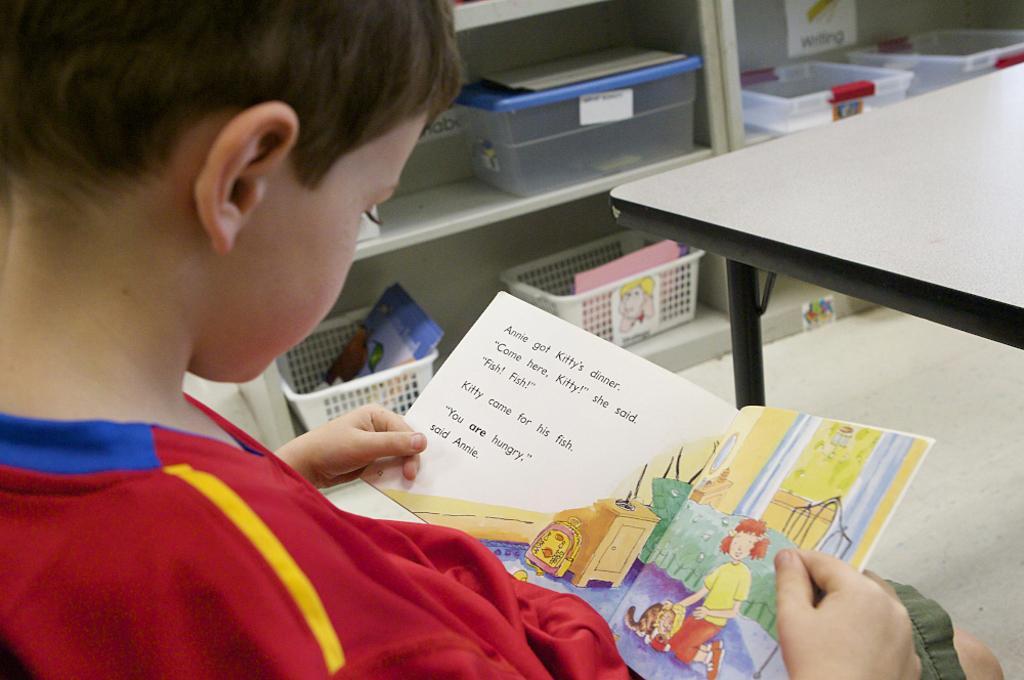Could you give a brief overview of what you see in this image? In this image we can see a child holding a book. On the right side there is a table. In the back there is a rack with boxes. There are some items in the boxes. 